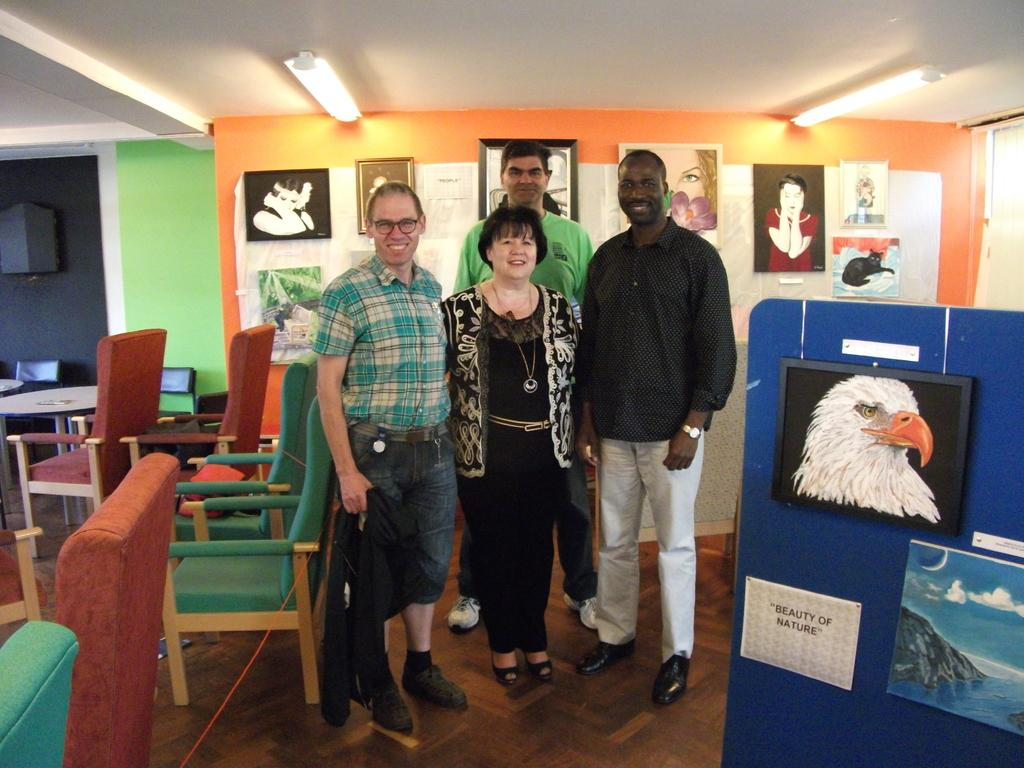How many people are in the image? There are four persons standing in the image. What type of furniture is visible in the image? Chairs and tables are present in the image. What can be seen on the walls in the image? There are posters and pictures on the wall. What is visible at the top of the image? Lights are visible at the top of the image. What type of plants can be seen growing on the ceiling in the image? There are no plants visible in the image, let alone growing on the ceiling. 